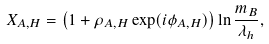<formula> <loc_0><loc_0><loc_500><loc_500>X _ { A , H } = \left ( 1 + \rho _ { A , H } \exp ( i \phi _ { A , H } ) \right ) \ln \frac { m _ { B } } { \lambda _ { h } } ,</formula> 